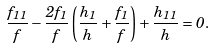Convert formula to latex. <formula><loc_0><loc_0><loc_500><loc_500>\frac { f _ { 1 1 } } { f } - \frac { 2 f _ { 1 } } { f } \left ( \frac { h _ { 1 } } { h } + \frac { f _ { 1 } } { f } \right ) + \frac { h _ { 1 1 } } { h } = 0 .</formula> 